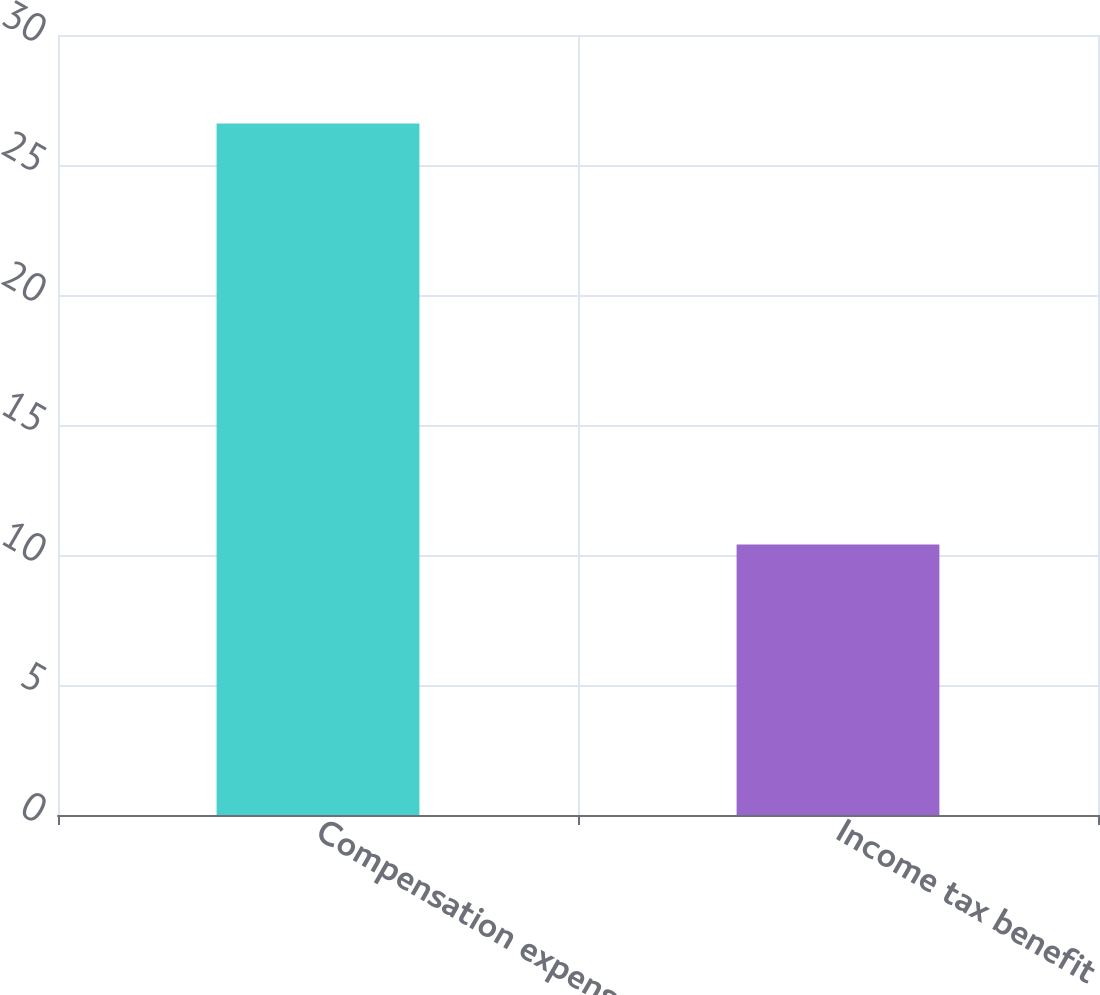Convert chart to OTSL. <chart><loc_0><loc_0><loc_500><loc_500><bar_chart><fcel>Compensation expense<fcel>Income tax benefit<nl><fcel>26.6<fcel>10.4<nl></chart> 